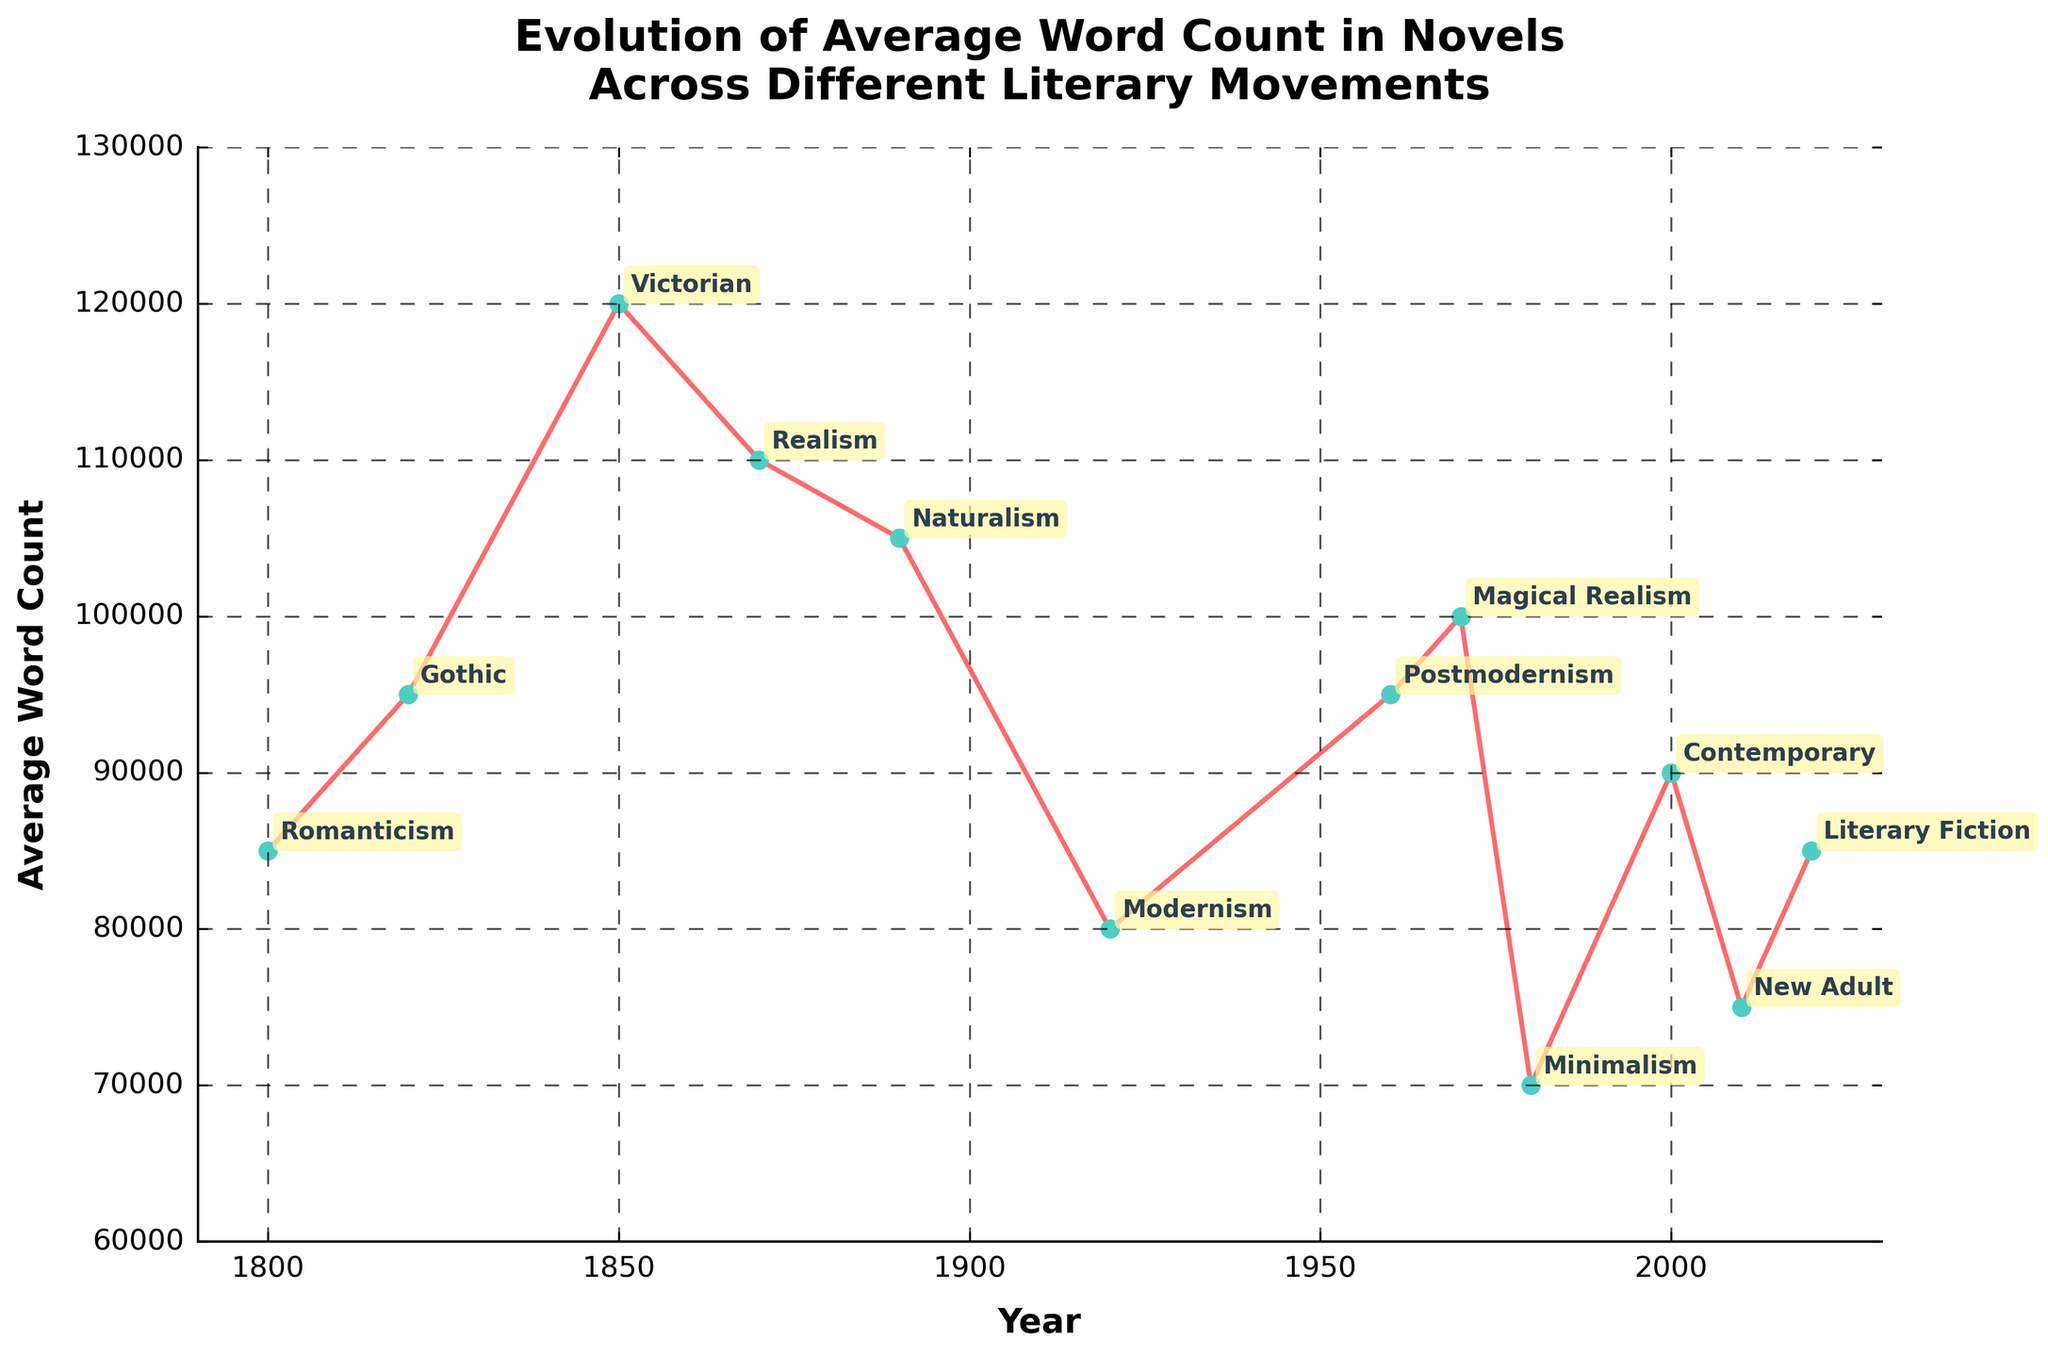Which literary movement has the highest average word count? To find the literary movement with the highest average word count, look at the data points and compare their values. Gothic has the highest point at 95,000 words.
Answer: Gothic What is the difference in average word count between Victorian and Minimalism novels? Subtract the average word count of Minimalism (70,000) from Victorian (120,000). 120,000 - 70,000 = 50,000.
Answer: 50,000 How did the average word count change from Modernism to Minimalism? Find the data points for Modernism (1920) and Minimalism (1980). Subtract the word count for Minimalism (70,000) from Modernism (80,000). 80,000 - 70,000 = 10,000.
Answer: Decreased by 10,000 Is there a trend in the average word count of novels after 1980? Observe the data points from 1980 (Minimalism, Postmodernism, Magical Realism, Contemporary, New Adult, Literary Fiction). The average word count increased after 1980 (70,000) to 90,000 (Contemporary in 2000), with some fluctuations.
Answer: Slight upward trend with fluctuations In which period did the average word count decrease the most compared to the previous movement? Compare the average word counts of successive literary movements. The most significant decrease is from 120,000 (Victorian) to 110,000 (Realism), a drop of 10,000 words.
Answer: From Victorian to Realism How does the average word count of Contemporary novels compare to Romanticism? Compare the data points for Contemporary (2000) with Romanticism (1800). Contemporary has 90,000 words while Romanticism has 85,000 words. 90,000 is greater than 85,000.
Answer: Contemporary is higher What is the sum of the average word counts for the movements between the years 1890 and 2000? Sum the average word counts for Naturalism (105,000), Modernism (80,000), Postmodernism (95,000), Magical Realism (100,000), Minimalism (70,000), and Contemporary (90,000). 105,000 + 80,000 + 95,000 + 100,000 + 70,000 + 90,000 = 540,000.
Answer: 540,000 Which movements have an average word count that is exactly the same? Compare the data points. Both Romanticism (1800) and Literary Fiction (2020) have an average word count of 85,000.
Answer: Romanticism and Literary Fiction 